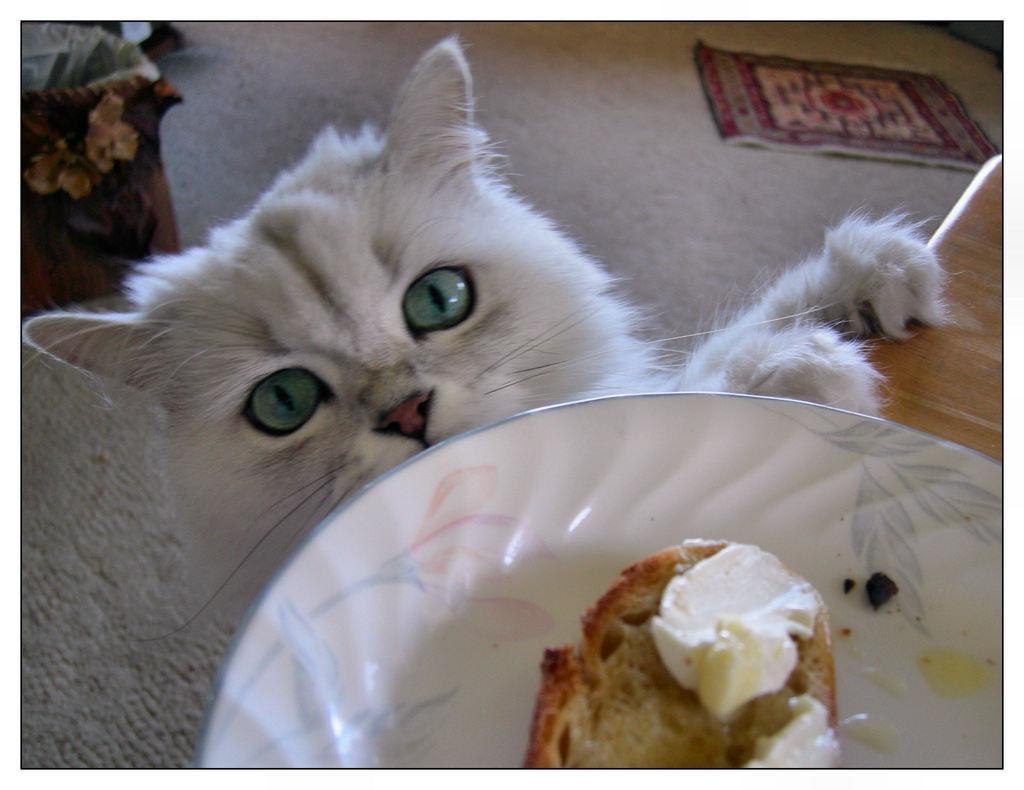Please provide a concise description of this image. In the center of the image we can see a cat. At the bottom of the image we can see a table. On the table we can see a plate which contains dessert. In the background of the image we can see the carpet, door mat and the couch. 